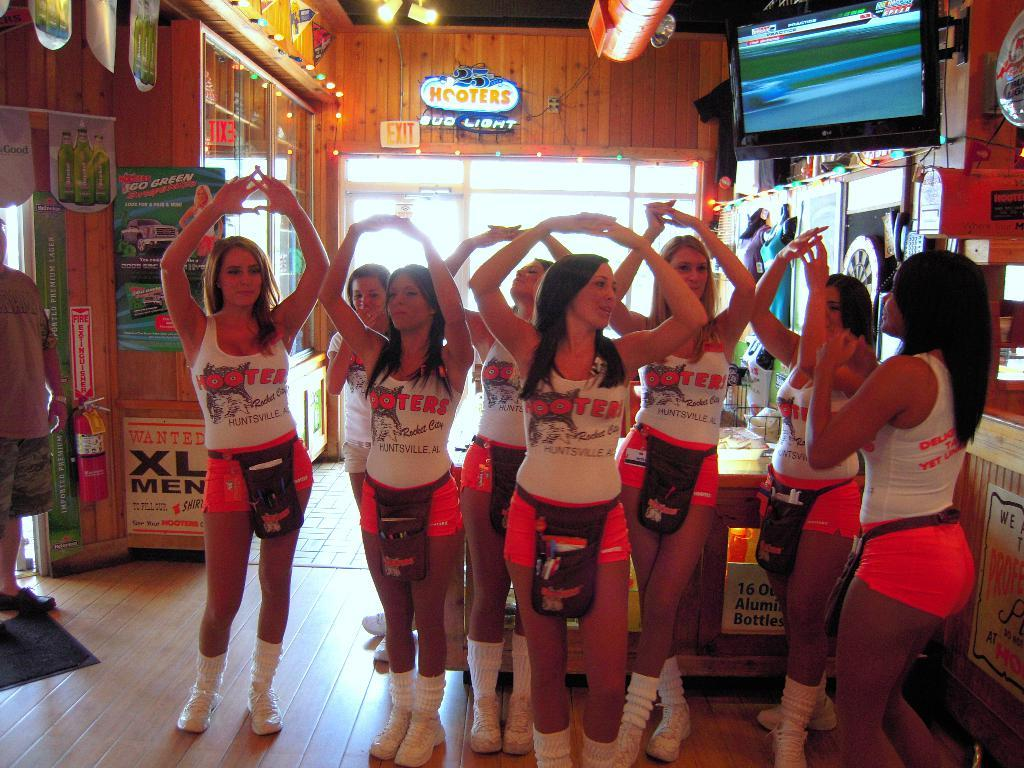<image>
Provide a brief description of the given image. Women wearing Hooters shirts stand around with their arms over their heads. 